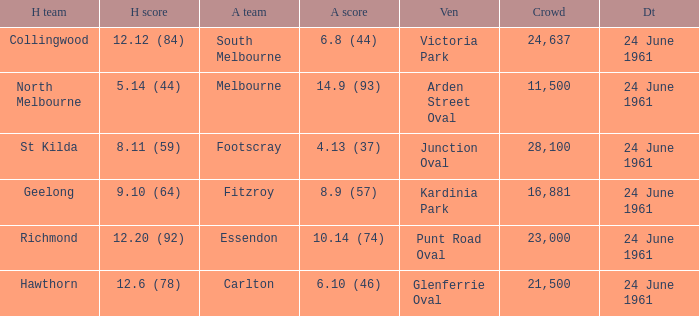Who was the home team that scored 12.6 (78)? Hawthorn. 